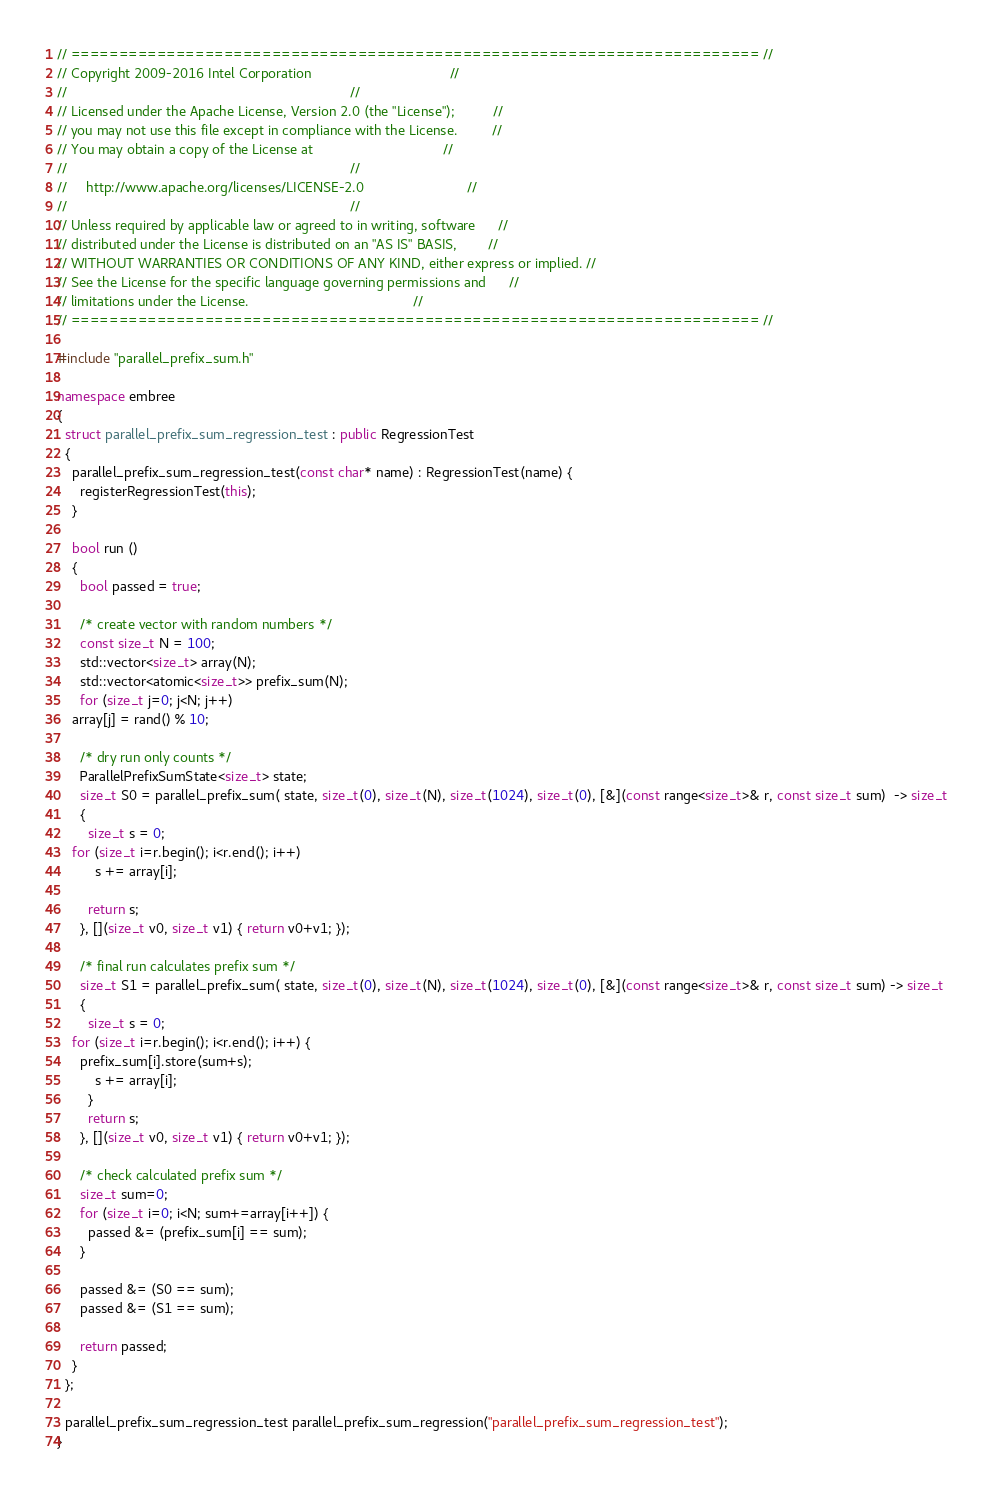<code> <loc_0><loc_0><loc_500><loc_500><_C++_>// ======================================================================== //
// Copyright 2009-2016 Intel Corporation                                    //
//                                                                          //
// Licensed under the Apache License, Version 2.0 (the "License");          //
// you may not use this file except in compliance with the License.         //
// You may obtain a copy of the License at                                  //
//                                                                          //
//     http://www.apache.org/licenses/LICENSE-2.0                           //
//                                                                          //
// Unless required by applicable law or agreed to in writing, software      //
// distributed under the License is distributed on an "AS IS" BASIS,        //
// WITHOUT WARRANTIES OR CONDITIONS OF ANY KIND, either express or implied. //
// See the License for the specific language governing permissions and      //
// limitations under the License.                                           //
// ======================================================================== //

#include "parallel_prefix_sum.h"

namespace embree
{
  struct parallel_prefix_sum_regression_test : public RegressionTest
  {
    parallel_prefix_sum_regression_test(const char* name) : RegressionTest(name) {
      registerRegressionTest(this);
    }
    
    bool run ()
    {
      bool passed = true;

      /* create vector with random numbers */
      const size_t N = 100;
      std::vector<size_t> array(N);
      std::vector<atomic<size_t>> prefix_sum(N);
      for (size_t j=0; j<N; j++)
	array[j] = rand() % 10;
  
      /* dry run only counts */
      ParallelPrefixSumState<size_t> state;
      size_t S0 = parallel_prefix_sum( state, size_t(0), size_t(N), size_t(1024), size_t(0), [&](const range<size_t>& r, const size_t sum)  -> size_t
      {
        size_t s = 0;
	for (size_t i=r.begin(); i<r.end(); i++)
          s += array[i];
	
        return s;
      }, [](size_t v0, size_t v1) { return v0+v1; });
      
      /* final run calculates prefix sum */
      size_t S1 = parallel_prefix_sum( state, size_t(0), size_t(N), size_t(1024), size_t(0), [&](const range<size_t>& r, const size_t sum) -> size_t
      {
        size_t s = 0;
	for (size_t i=r.begin(); i<r.end(); i++) {
	  prefix_sum[i].store(sum+s);
          s += array[i];
        }
        return s;
      }, [](size_t v0, size_t v1) { return v0+v1; });

      /* check calculated prefix sum */
      size_t sum=0;
      for (size_t i=0; i<N; sum+=array[i++]) {
        passed &= (prefix_sum[i] == sum);
      }

      passed &= (S0 == sum);
      passed &= (S1 == sum);

      return passed;
    }
  };

  parallel_prefix_sum_regression_test parallel_prefix_sum_regression("parallel_prefix_sum_regression_test");
}
</code> 